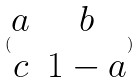<formula> <loc_0><loc_0><loc_500><loc_500>( \begin{matrix} a & b \\ c & 1 - a \end{matrix} )</formula> 